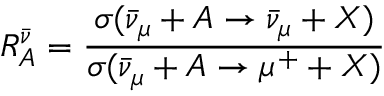<formula> <loc_0><loc_0><loc_500><loc_500>R _ { A } ^ { \bar { \nu } } = \frac { \sigma ( \bar { \nu } _ { \mu } + A \to \bar { \nu } _ { \mu } + X ) } { \sigma ( \bar { \nu } _ { \mu } + A \to \mu ^ { + } + X ) }</formula> 